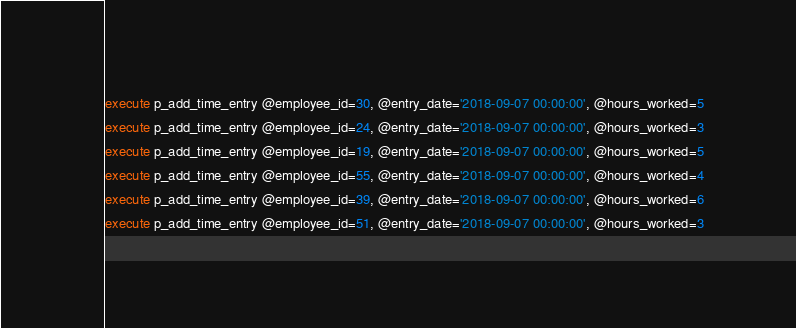<code> <loc_0><loc_0><loc_500><loc_500><_SQL_>execute p_add_time_entry @employee_id=30, @entry_date='2018-09-07 00:00:00', @hours_worked=5
execute p_add_time_entry @employee_id=24, @entry_date='2018-09-07 00:00:00', @hours_worked=3
execute p_add_time_entry @employee_id=19, @entry_date='2018-09-07 00:00:00', @hours_worked=5
execute p_add_time_entry @employee_id=55, @entry_date='2018-09-07 00:00:00', @hours_worked=4
execute p_add_time_entry @employee_id=39, @entry_date='2018-09-07 00:00:00', @hours_worked=6
execute p_add_time_entry @employee_id=51, @entry_date='2018-09-07 00:00:00', @hours_worked=3

</code> 